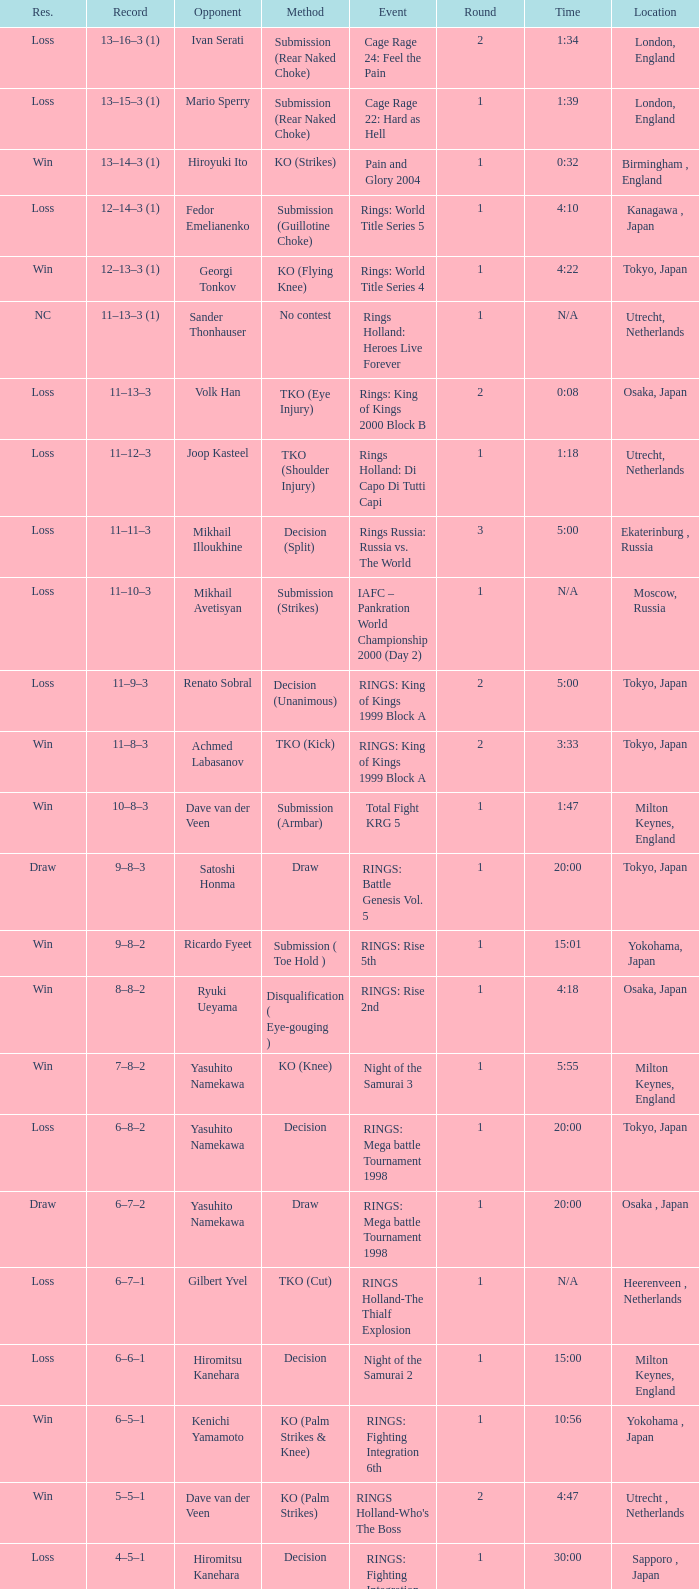What is the time for an opponent of Satoshi Honma? 20:00. 